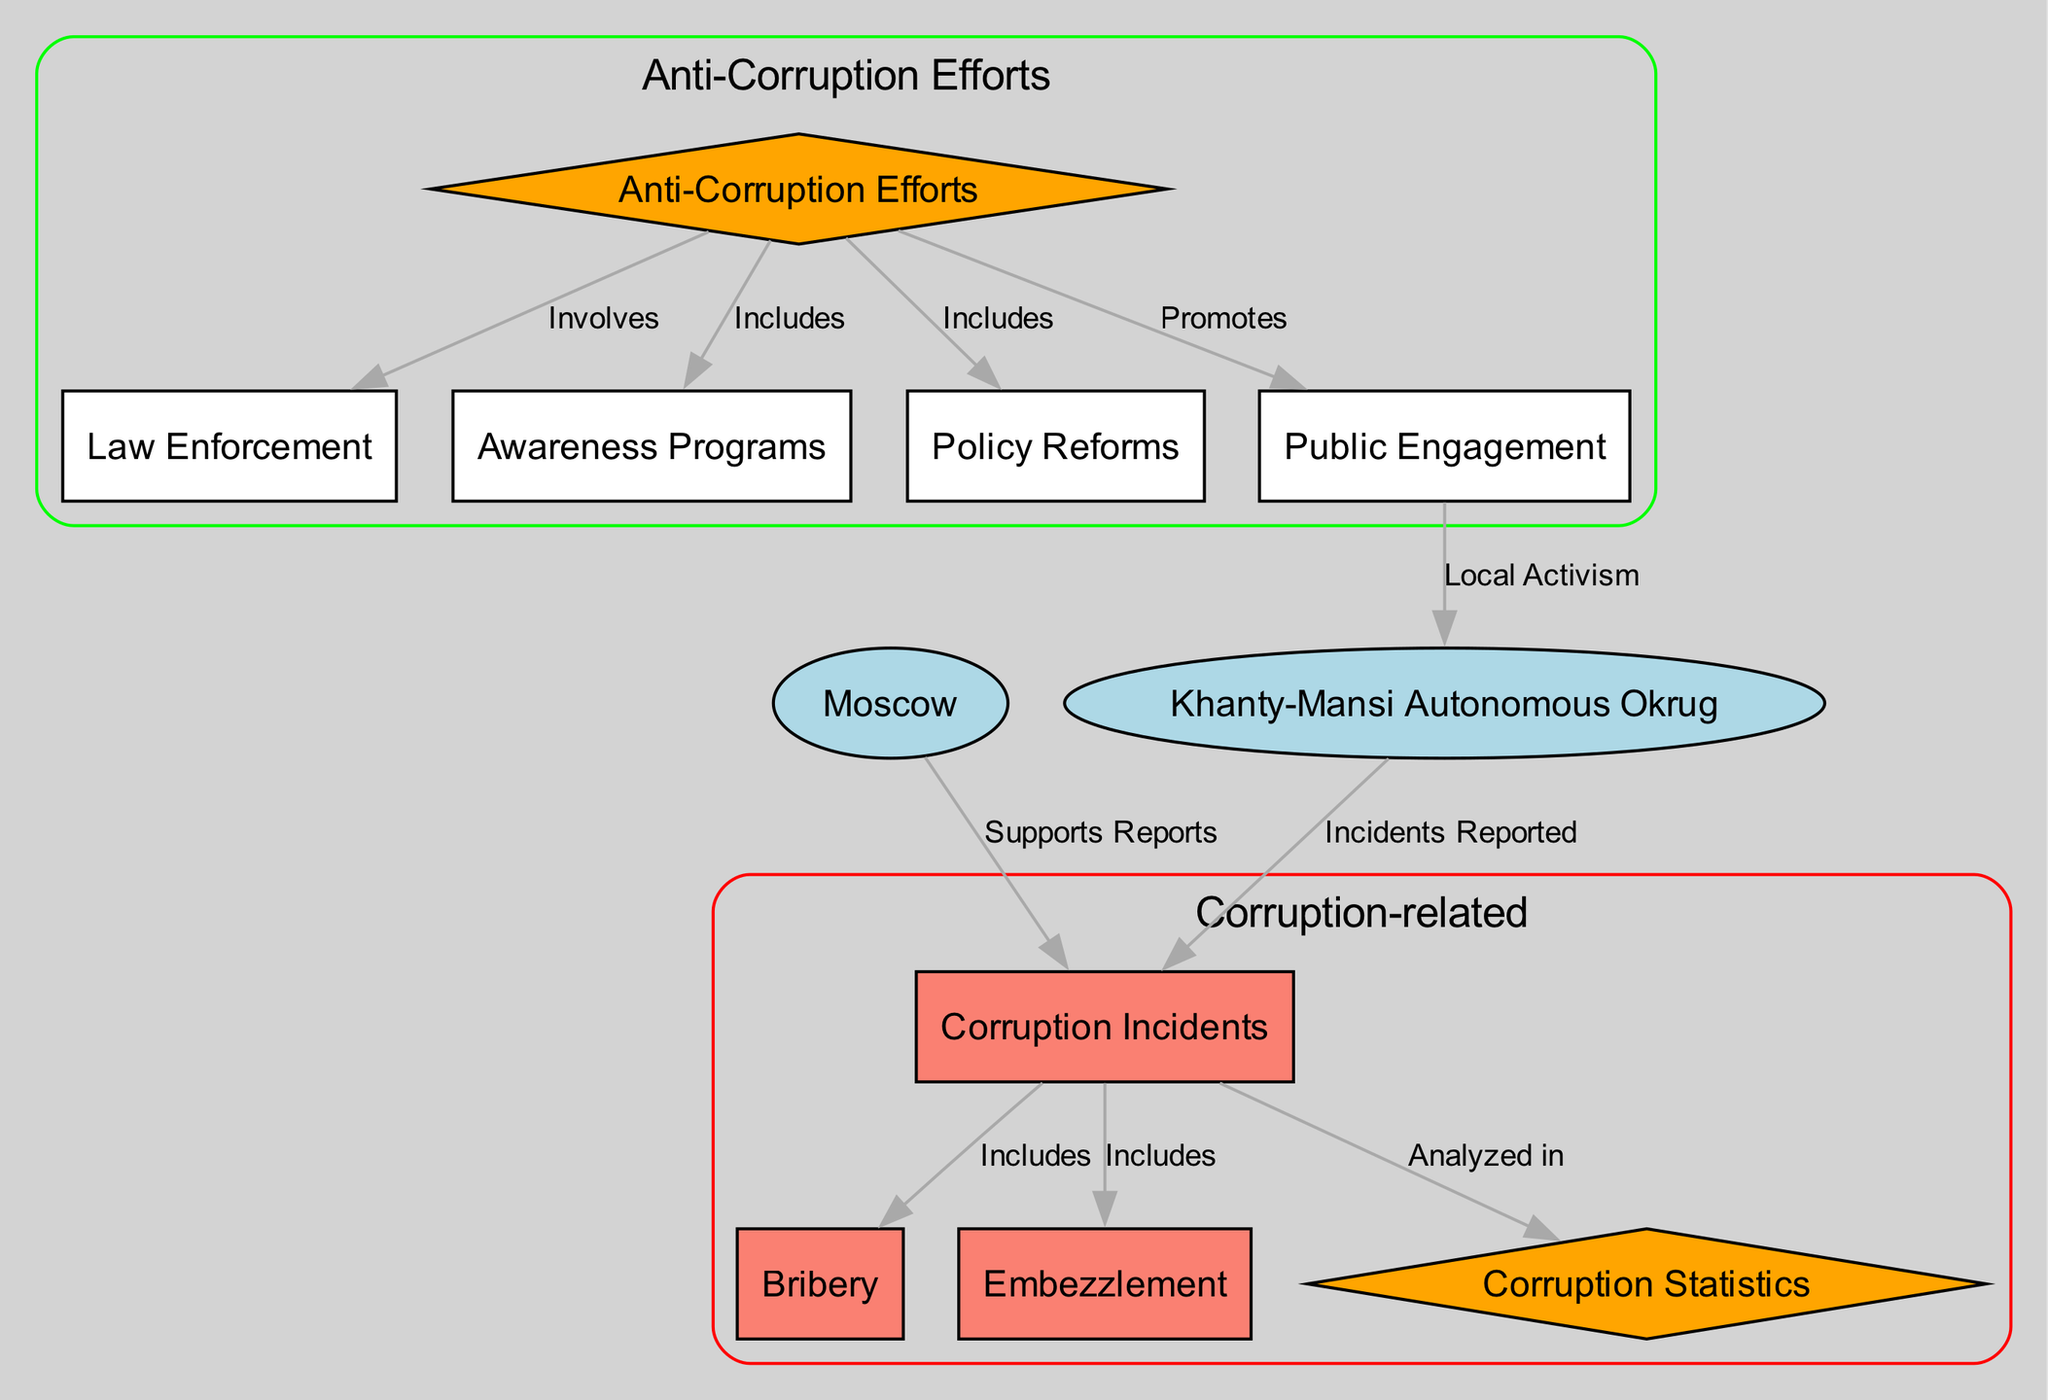What is the total number of nodes in the diagram? The diagram contains 11 nodes, which can be counted directly from the "nodes" section of the data: "corruption_incidents", "anti_corruption_efforts", "region_moscow", "region_khanty_mansi", "incident_bribery", "incident_embezzlement", "law_enforcement", "awareness_programs", "policy_reforms", "corruption_statistics", and "public_engagement".
Answer: 11 What types of corruption incidents are included? The diagram includes two types of corruption incidents: "Bribery" and "Embezzlement". This information can be found under the "Includes" relationships stemming from the "corruption_incidents" node.
Answer: Bribery, Embezzlement Which region supports reports of corruption incidents? The "region_moscow" node indicates that this region supports reports of corruption incidents as seen from the edge connecting "region_moscow" to "corruption_incidents" labeled "Supports Reports".
Answer: Moscow What anti-corruption effort involves law enforcement? The diagram identifies "Law Enforcement" as a component of "Anti-Corruption Efforts", represented by the edge that connects them labeled "Involves".
Answer: Law Enforcement How many types of anti-corruption efforts are illustrated? The diagram illustrates three types of anti-corruption efforts: "Law Enforcement", "Awareness Programs", and "Policy Reforms". This is determined by counting the nodes that branch off from the "anti_corruption_efforts" node.
Answer: 3 What is promoted by public engagement? The diagram shows that "Public Engagement" promotes "Local Activism", as indicated by the edge connecting "public_engagement" to "region_khanty_mansi" labeled "Local Activism".
Answer: Local Activism What type of incidents are analyzed in corruption statistics? The "corruption_statistics" node is linked to the "corruption_incidents" node by an edge labeled "Analyzed in", implying that all incidents, including bribery and embezzlement, are reflected in the statistics.
Answer: Corruption Incidents Which anti-corruption effort includes awareness programs? The diagram specifies that "Awareness Programs" are included in "Anti-Corruption Efforts", indicated by the relevant edge connecting these two nodes labeled "Includes".
Answer: Awareness Programs Which node indicates local activism related to public engagement? The "region_khanty_mansi" node is the one that connects to "public_engagement" which indicates local activism. This connection is evident from the labeled edge "Local Activism".
Answer: Khanty-Mansi Autonomous Okrug 